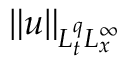<formula> <loc_0><loc_0><loc_500><loc_500>\| u \| _ { L _ { t } ^ { q } L _ { x } ^ { \infty } }</formula> 